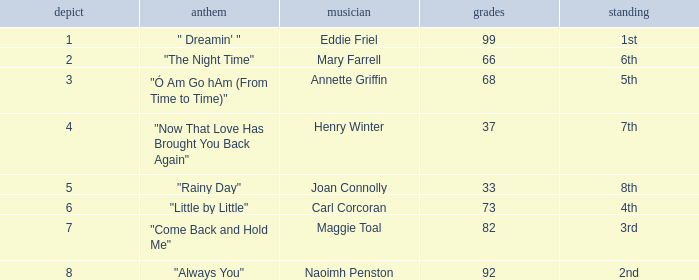Which song has more than 66 points, a draw greater than 3, and is ranked 3rd? "Come Back and Hold Me". 